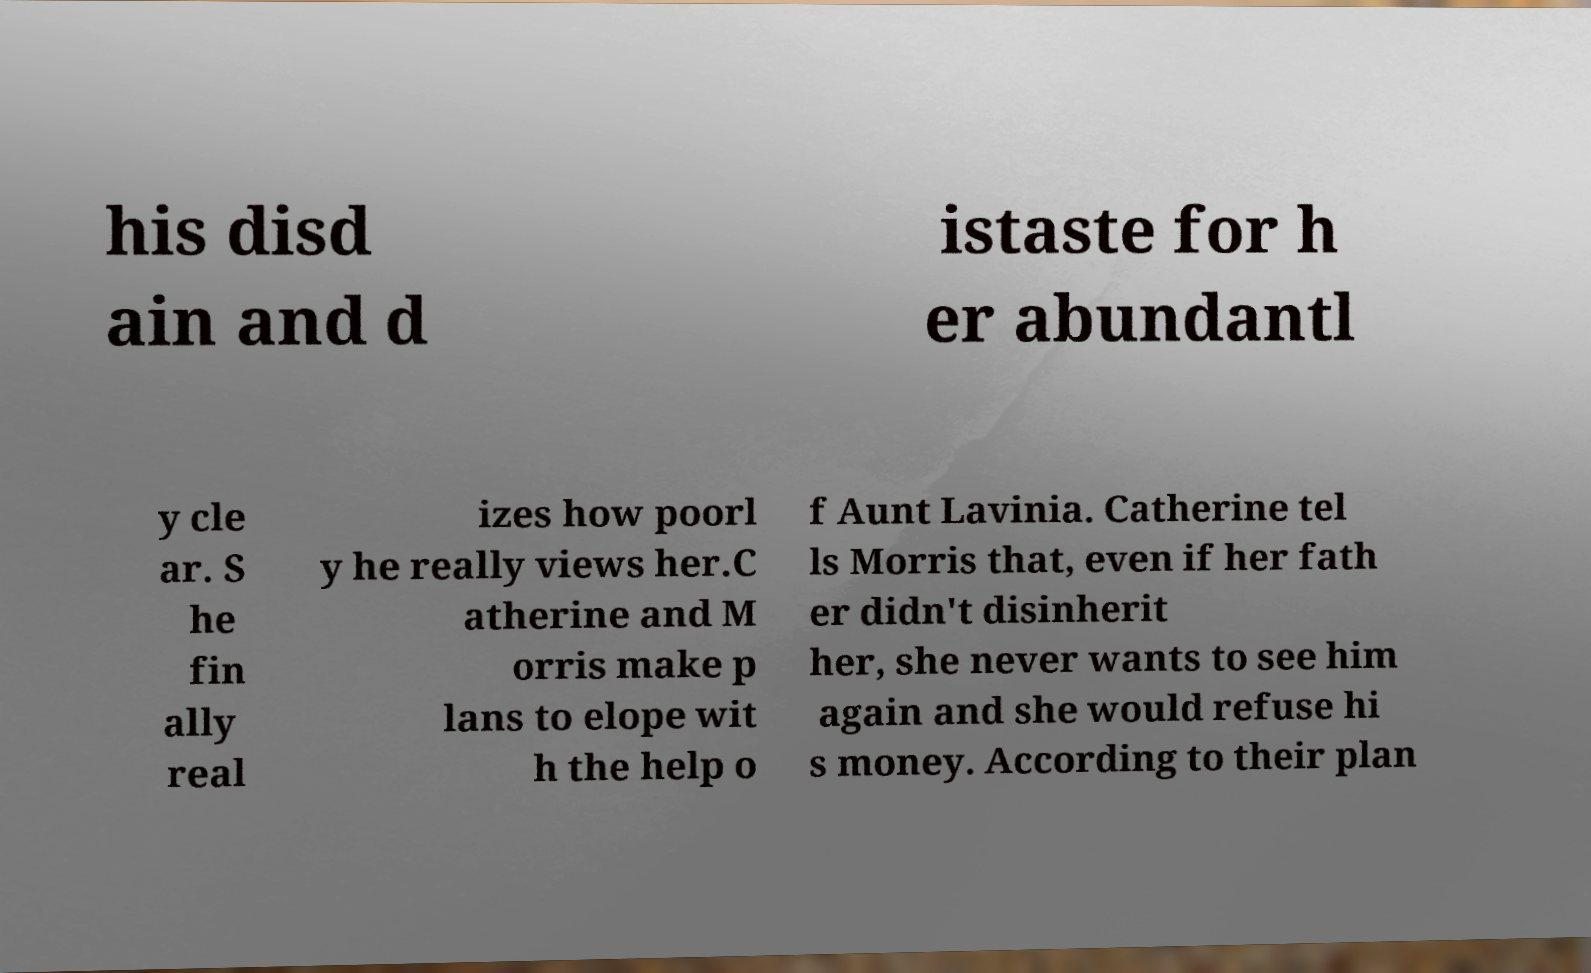For documentation purposes, I need the text within this image transcribed. Could you provide that? his disd ain and d istaste for h er abundantl y cle ar. S he fin ally real izes how poorl y he really views her.C atherine and M orris make p lans to elope wit h the help o f Aunt Lavinia. Catherine tel ls Morris that, even if her fath er didn't disinherit her, she never wants to see him again and she would refuse hi s money. According to their plan 